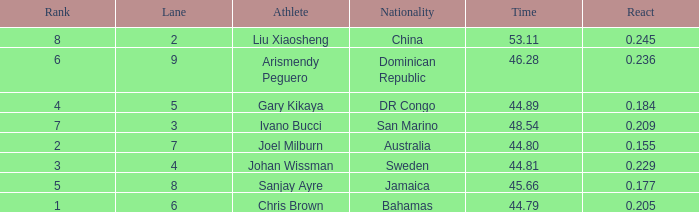Can you give me this table as a dict? {'header': ['Rank', 'Lane', 'Athlete', 'Nationality', 'Time', 'React'], 'rows': [['8', '2', 'Liu Xiaosheng', 'China', '53.11', '0.245'], ['6', '9', 'Arismendy Peguero', 'Dominican Republic', '46.28', '0.236'], ['4', '5', 'Gary Kikaya', 'DR Congo', '44.89', '0.184'], ['7', '3', 'Ivano Bucci', 'San Marino', '48.54', '0.209'], ['2', '7', 'Joel Milburn', 'Australia', '44.80', '0.155'], ['3', '4', 'Johan Wissman', 'Sweden', '44.81', '0.229'], ['5', '8', 'Sanjay Ayre', 'Jamaica', '45.66', '0.177'], ['1', '6', 'Chris Brown', 'Bahamas', '44.79', '0.205']]} How many total Rank listings have Liu Xiaosheng listed as the athlete with a react entry that is smaller than 0.245? 0.0. 